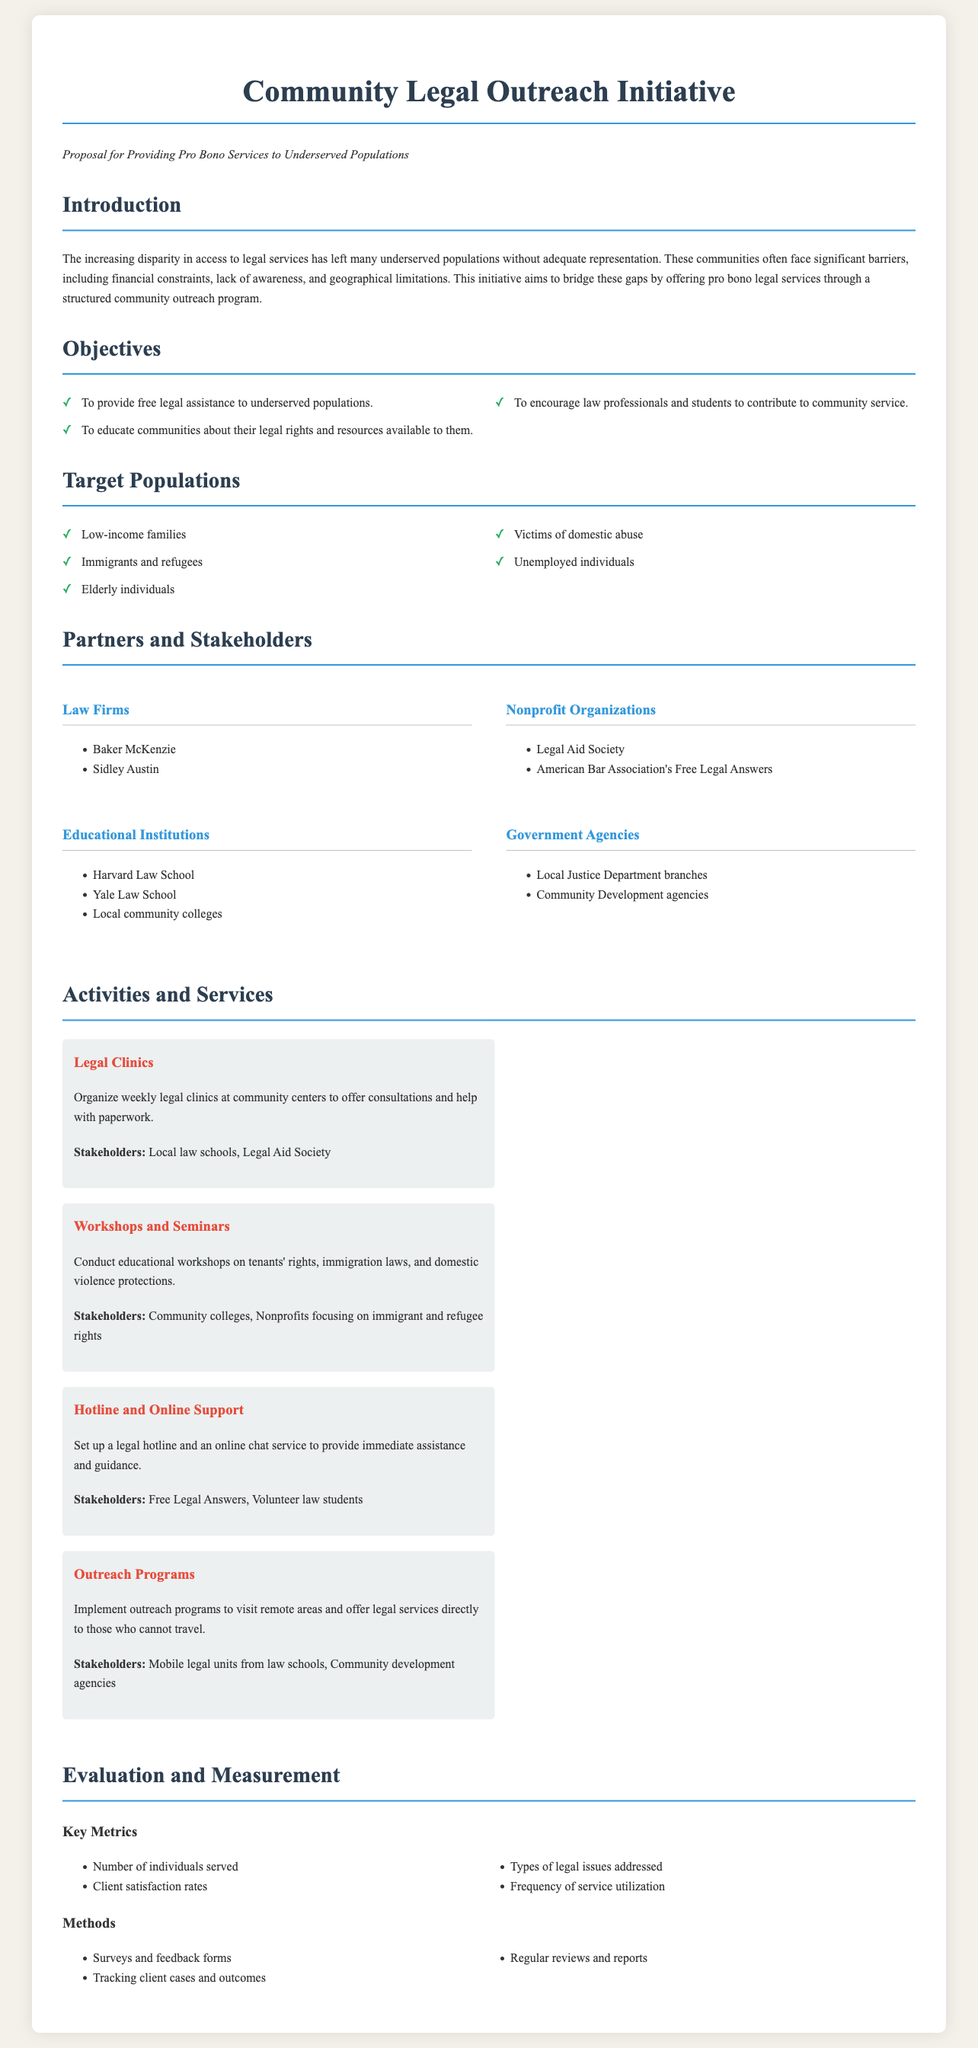What is the main goal of the Community Legal Outreach Initiative? The main goal is to bridge gaps in access to legal services for underserved populations.
Answer: bridge gaps in access to legal services How many law firms are listed as partners? The number of law firms listed is indicated in the partners section of the document.
Answer: 2 Name one target population mentioned in the proposal. A specific target population is mentioned in the target populations section of the document.
Answer: Low-income families What type of support does the hotline provide? The nature of support offered by the hotline is described in the activities section of the document.
Answer: immediate assistance What is one method of evaluation listed in the proposal? The methods of evaluation are detailed in the evaluation section of the document.
Answer: Surveys and feedback forms Which organization is mentioned as a partner that focuses on immigrant and refugee rights? The partners section of the document identifies organizations involved in the initiative.
Answer: Nonprofits focusing on immigrant and refugee rights How often will legal clinics be organized? The frequency of the legal clinics is described in the activities section of the document.
Answer: weekly What type of workshops will be conducted? The type of workshops is specified in the activities section of the document.
Answer: educational workshops How many key metrics are identified for evaluation? The number of key metrics is mentioned in the evaluation section of the document.
Answer: 4 